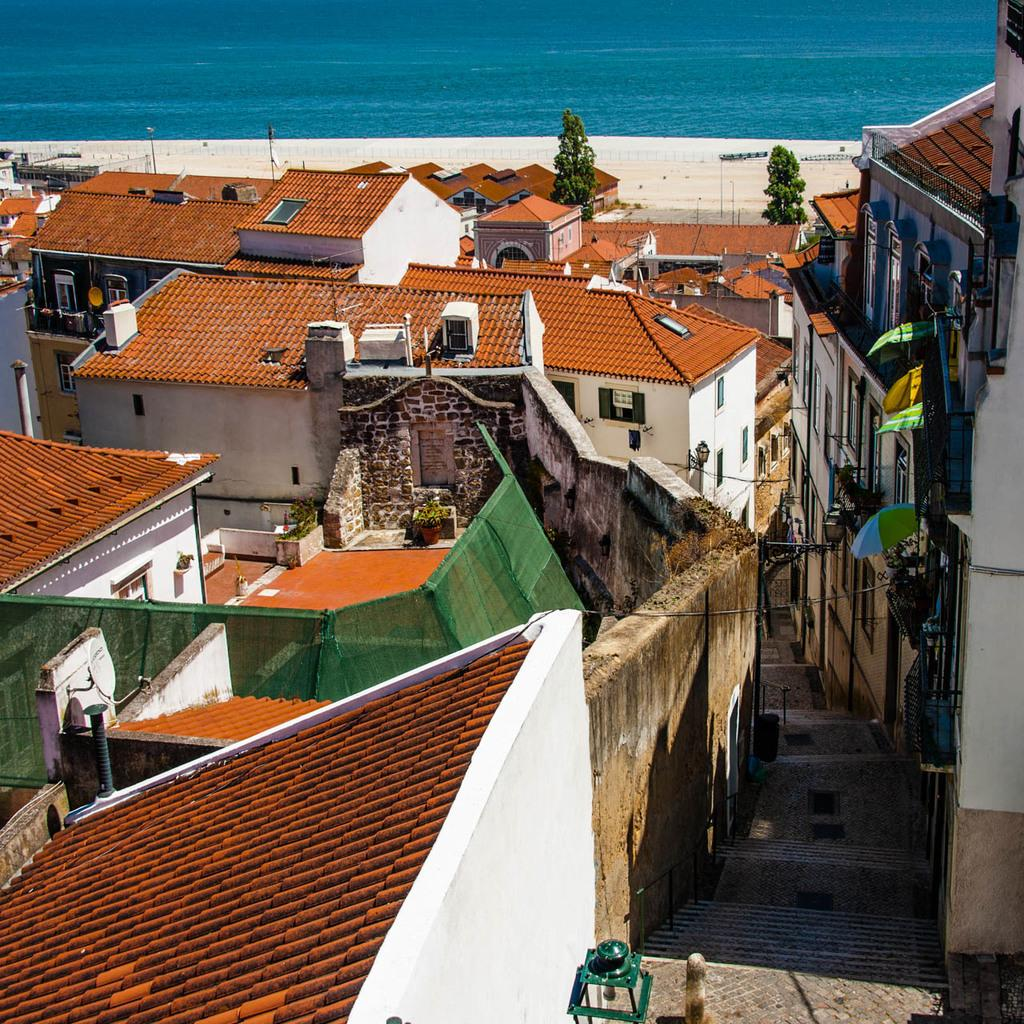What types of structures can be seen in the image? There are houses and buildings in the image. What natural elements are present in the image? There are trees and a beach in the image. What architectural features can be observed in the image? There is a fence, windows, light poles, steps, and a lamp in the image. Is there any water visible in the image? Yes, there is water visible in the image. Can you describe the possible location of the image based on the surroundings? The image may have been taken near the ocean, given the presence of a beach and the water. Can you tell me where the library is located in the image? There is no library present in the image. Is there any quicksand visible in the image? There is no quicksand present in the image. 